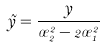Convert formula to latex. <formula><loc_0><loc_0><loc_500><loc_500>\tilde { y } = \frac { y } { \sigma _ { 2 } ^ { 2 } - 2 \sigma _ { 1 } ^ { 2 } }</formula> 